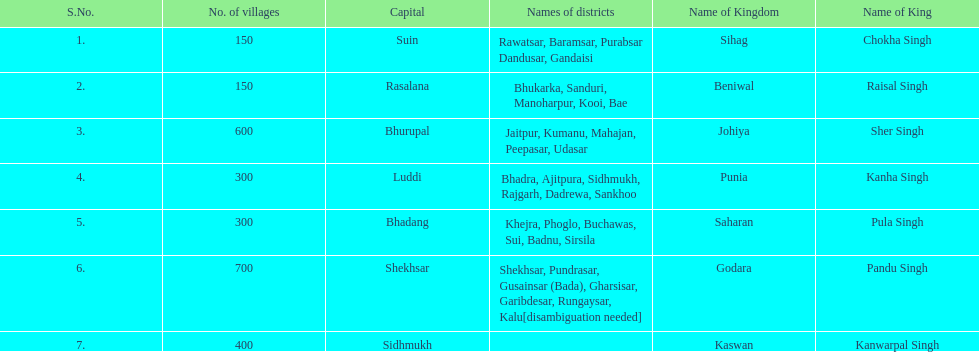How many districts does punia have? 6. 